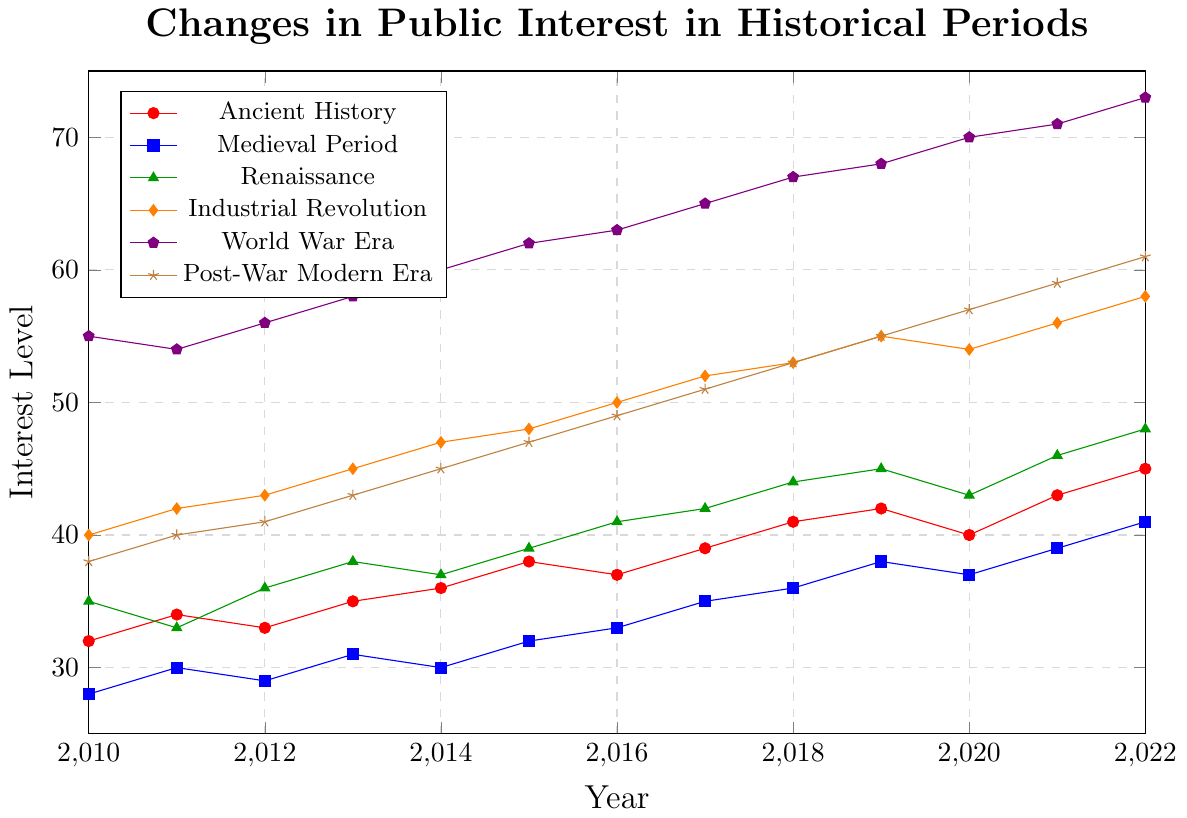Which historical period had the highest interest level in 2022? Look for the highest point in 2022 across all series in the chart, which is at the "World War Era" with a value of 73.
Answer: World War Era How did public interest in Ancient History change from 2010 to 2022? Identify the interest levels in 2010 and 2022 for Ancient History (32 in 2010 and 45 in 2022), then calculate the difference (45 - 32 = 13).
Answer: Increased by 13 Which historical period had the lowest interest level in 2014? Look for the lowest point in 2014 across all series, which is at the "Medieval Period" with a value of 30.
Answer: Medieval Period What was the average interest level in the Industrial Revolution between 2010 and 2020? Sum the interest levels for the Industrial Revolution from 2010 to 2020 (40 + 42 + 43 + 45 + 47 + 48 + 50 + 52 + 53 + 55 + 54 = 529), then divide by the number of years (11). The average is 529 / 11 ≈ 48.09.
Answer: 48.09 Which historical period showed the most significant increase in public interest from 2010 to 2022? Calculate the increase for each period: Ancient History (13), Medieval Period (13), Renaissance (13), Industrial Revolution (18), World War Era (18), Post-War Modern Era (23). The highest increase is for the Post-War Modern Era.
Answer: Post-War Modern Era Between which consecutive years did the Renaissance period see the highest increase in interest? Look at the changes between consecutive years for the Renaissance period: (33-35 and 2011-2012: +3, 2012-2013: +2, 2013-2014: -1, 2014-2015: +2, 2015-2016: +2, 2016-2017: +1, 2017-2018: +2, 2018-2019: +1, 2019-2020: -2, 2020-2021: +3), the highest increase is between 2020 and 2021 with +3.
Answer: 2020 and 2021 What was the difference in interest levels between the World War Era and the Medieval Period in 2016? Compare the interest levels for both periods in 2016 (World War Era: 63, Medieval Period: 33), then calculate the difference (63 - 33 = 30).
Answer: 30 Which period's interest level remained between 40 and 60 during the entire 2010-2022 span? Examine each period's interest levels over the years: the Industrial Revolution's values (40, 42, 43, 45, 47, 48, 50, 52, 53, 55, 54, 56, 58) all stay within the range of 40 and 60.
Answer: Industrial Revolution How did the interest in the Post-War Modern Era trend from 2010 to 2022? Identify the interest levels for the Post-War Modern Era from 2010 to 2022 (38 to 61), noting a consistent increase each year.
Answer: Consistently increased 